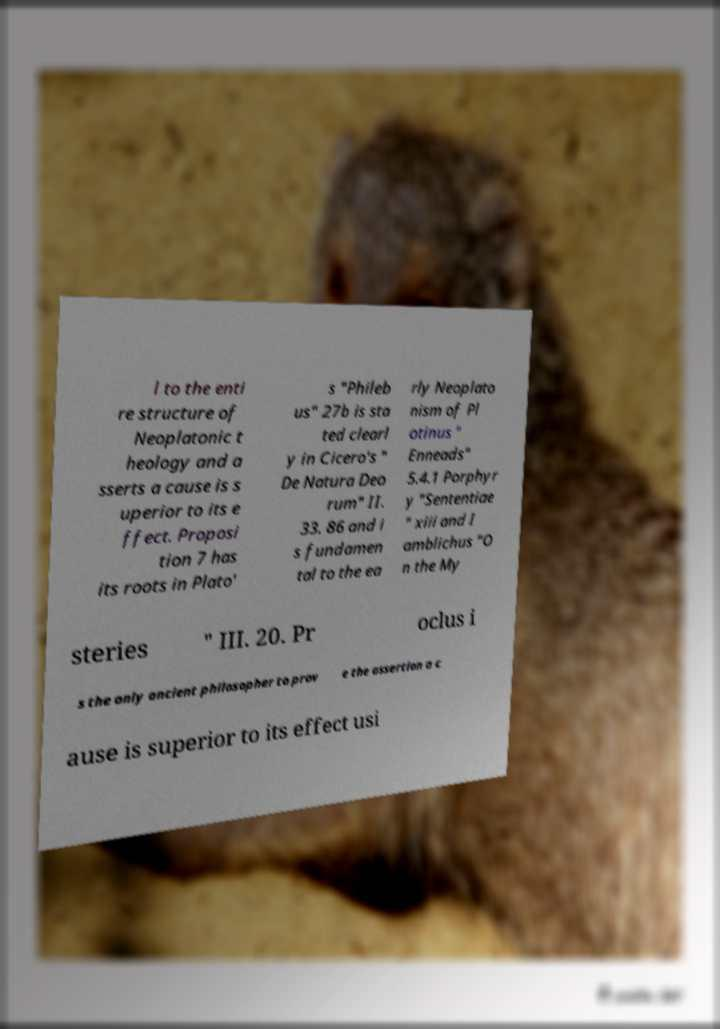Could you assist in decoding the text presented in this image and type it out clearly? l to the enti re structure of Neoplatonic t heology and a sserts a cause is s uperior to its e ffect. Proposi tion 7 has its roots in Plato' s "Phileb us" 27b is sta ted clearl y in Cicero's " De Natura Deo rum" II. 33. 86 and i s fundamen tal to the ea rly Neoplato nism of Pl otinus " Enneads" 5.4.1 Porphyr y "Sententiae " xiii and I amblichus "O n the My steries " III. 20. Pr oclus i s the only ancient philosopher to prov e the assertion a c ause is superior to its effect usi 